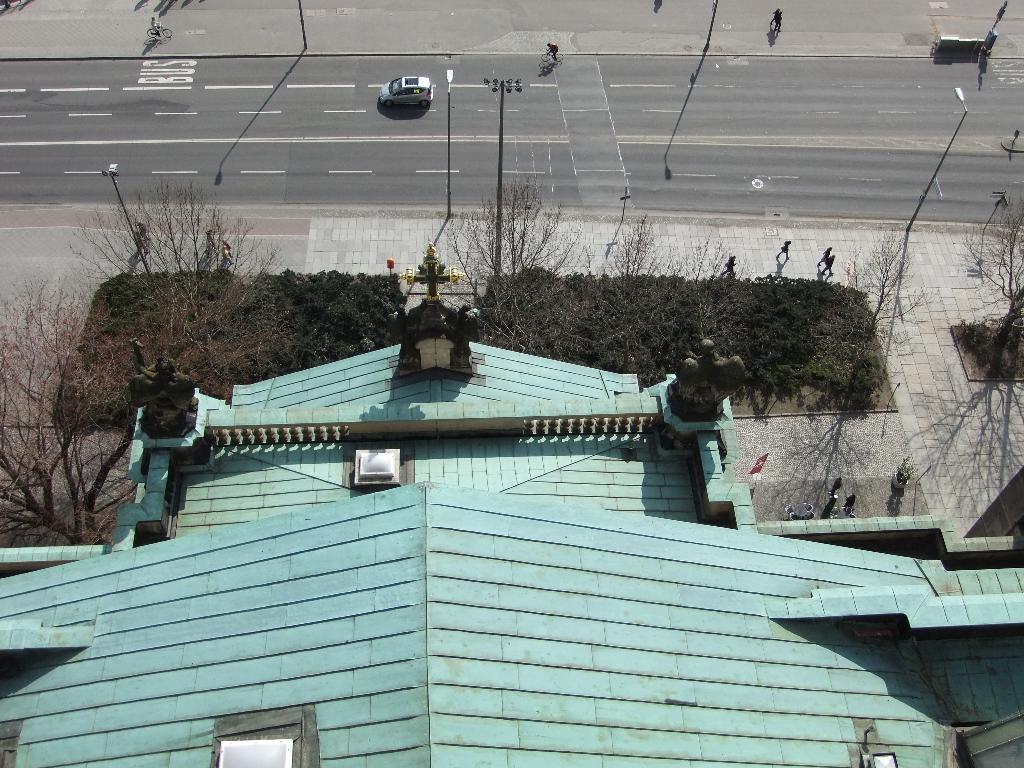Describe this image in one or two sentences. In the picture we can see an Aerial view of a house which is blue in color and on the path we can see some plants, trees and near to it there is a road with some vehicles on it. 